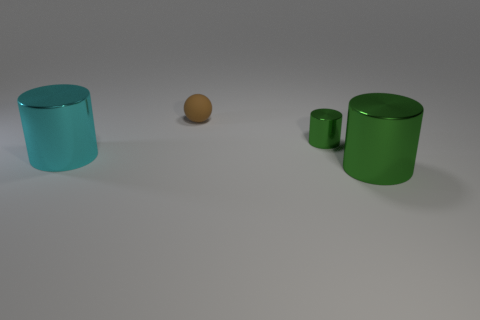Is there any other thing that has the same material as the small brown ball?
Give a very brief answer. No. There is a large green thing that is the same shape as the tiny metallic thing; what is its material?
Provide a short and direct response. Metal. What is the color of the rubber sphere?
Your response must be concise. Brown. The shiny thing that is behind the large metal cylinder that is to the left of the tiny green metallic thing is what color?
Your answer should be very brief. Green. There is a small metallic cylinder; is it the same color as the large metallic cylinder that is to the right of the matte object?
Keep it short and to the point. Yes. There is a green thing that is left of the thing that is on the right side of the small metal object; how many big shiny things are to the right of it?
Your answer should be very brief. 1. Are there any matte objects behind the small brown ball?
Make the answer very short. No. Is there any other thing that has the same color as the small cylinder?
Offer a very short reply. Yes. How many balls are either tiny green things or brown matte things?
Provide a succinct answer. 1. How many small objects are both to the left of the tiny green metallic object and in front of the small brown ball?
Provide a succinct answer. 0. 